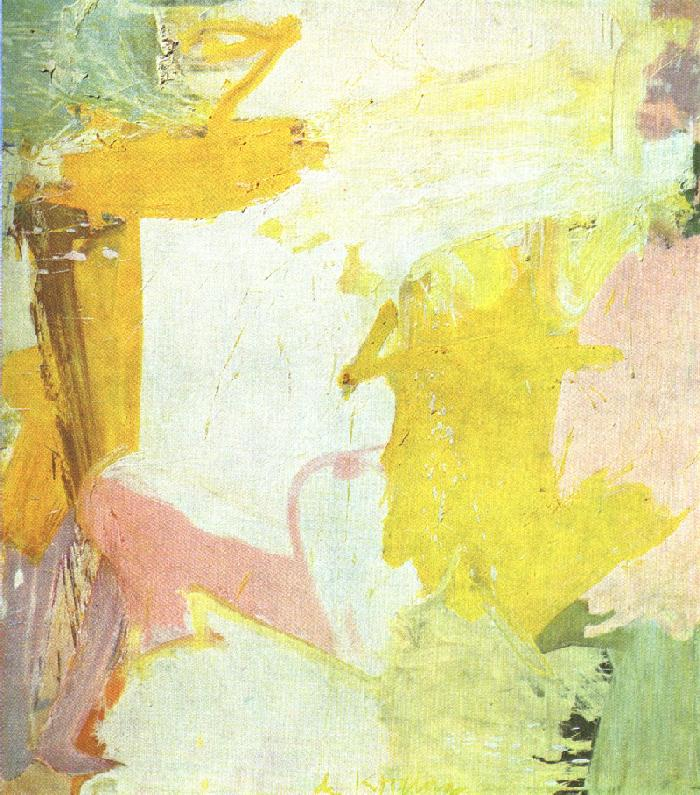Imagine if this artwork came to life. What would it look, feel, and sound like? If this artwork came to life, it would be a mesmerizing dance of light and color. The hues of yellow would shimmer like sunlight filtering through the leaves, casting a warm and inviting glow. The pink shades would flow like a gentle breeze, carrying the fragrance of blooming flowers. The soft white and pastel colors would create an ethereal atmosphere, akin to walking through a dreamlike landscape. It would feel like walking on clouds, with each step as light as a feather. The sound accompanying this living artwork would be a symphony of nature; birds chirping, leaves rustling, and a distant melody of a flowing brook, all blending into a harmonious symphony that soothes the soul. What might this piece suggest about the artist's state of mind or inspiration? This piece suggests that the artist was in a state of peaceful contemplation while creating it. The use of soft, pastel colors and flowing brushstrokes indicates a calm and serene mindset. The choice of colors and the abstract nature of the painting might also reflect a sense of joy and contentment, an inspiration drawn from simple, everyday beauty and positive emotions. It seems the artist was inspired by a desire to convey a tranquil and uplifting atmosphere, allowing those who view the piece to share in that moment of peace and happiness. 